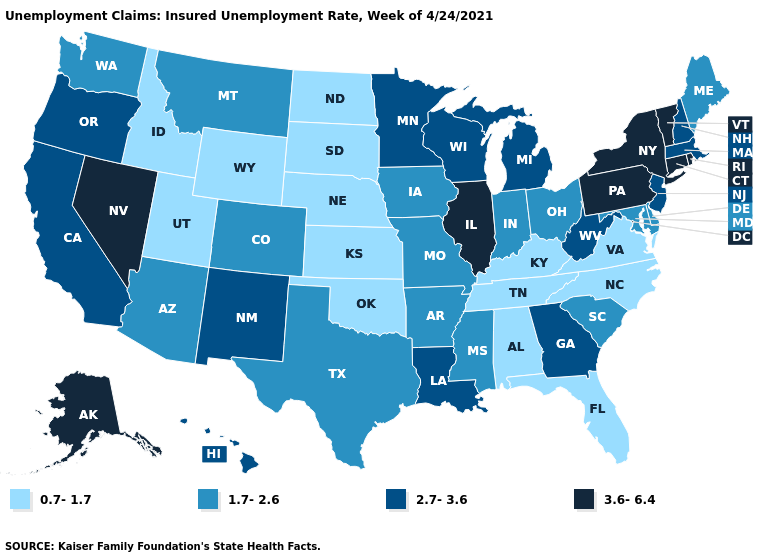Among the states that border Missouri , does Iowa have the lowest value?
Quick response, please. No. Does New Mexico have a higher value than Minnesota?
Write a very short answer. No. Among the states that border Oklahoma , does Kansas have the lowest value?
Concise answer only. Yes. Which states have the lowest value in the USA?
Write a very short answer. Alabama, Florida, Idaho, Kansas, Kentucky, Nebraska, North Carolina, North Dakota, Oklahoma, South Dakota, Tennessee, Utah, Virginia, Wyoming. Name the states that have a value in the range 2.7-3.6?
Keep it brief. California, Georgia, Hawaii, Louisiana, Massachusetts, Michigan, Minnesota, New Hampshire, New Jersey, New Mexico, Oregon, West Virginia, Wisconsin. What is the highest value in the MidWest ?
Short answer required. 3.6-6.4. What is the value of Montana?
Concise answer only. 1.7-2.6. What is the highest value in states that border Oklahoma?
Short answer required. 2.7-3.6. Does Arkansas have the highest value in the USA?
Keep it brief. No. Name the states that have a value in the range 0.7-1.7?
Quick response, please. Alabama, Florida, Idaho, Kansas, Kentucky, Nebraska, North Carolina, North Dakota, Oklahoma, South Dakota, Tennessee, Utah, Virginia, Wyoming. Does the map have missing data?
Answer briefly. No. Does the first symbol in the legend represent the smallest category?
Short answer required. Yes. Name the states that have a value in the range 3.6-6.4?
Give a very brief answer. Alaska, Connecticut, Illinois, Nevada, New York, Pennsylvania, Rhode Island, Vermont. Does the map have missing data?
Keep it brief. No. Name the states that have a value in the range 1.7-2.6?
Quick response, please. Arizona, Arkansas, Colorado, Delaware, Indiana, Iowa, Maine, Maryland, Mississippi, Missouri, Montana, Ohio, South Carolina, Texas, Washington. 